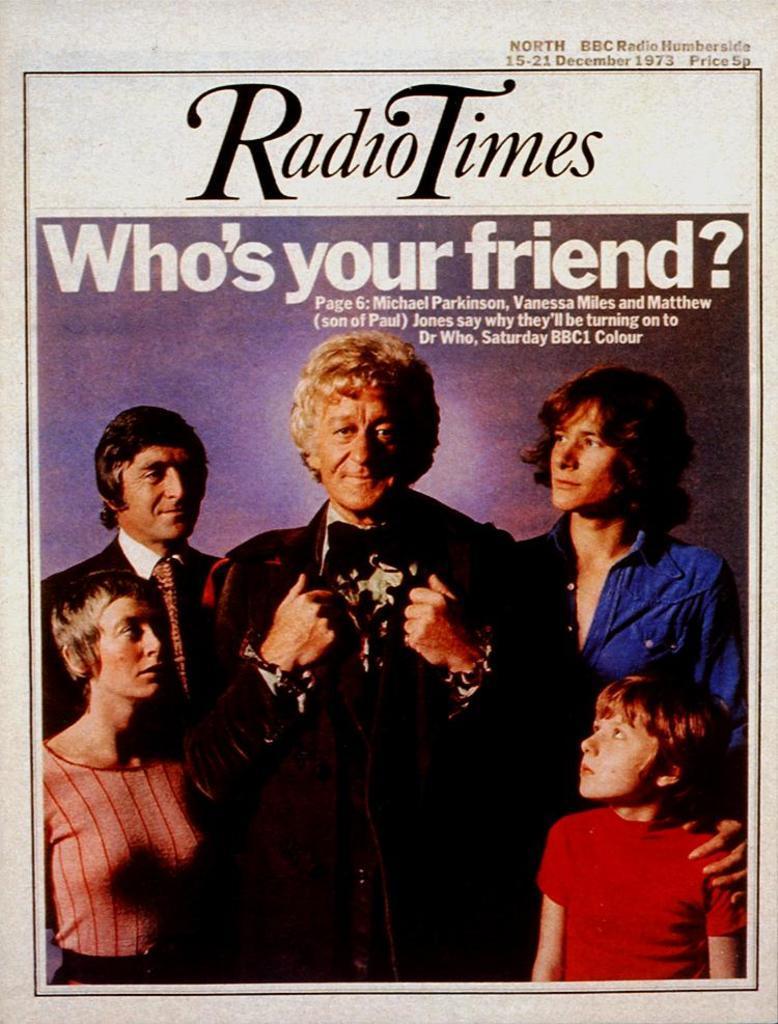Could you give a brief overview of what you see in this image? In the center of this picture we can see a white color object seems to be a poster and we can see the text and numbers on the poster, we can see the pictures of group of persons standing and a picture of a woman wearing t-shirt and standing. On the right we can see the picture of a kid wearing red color t-shirt and standing. 